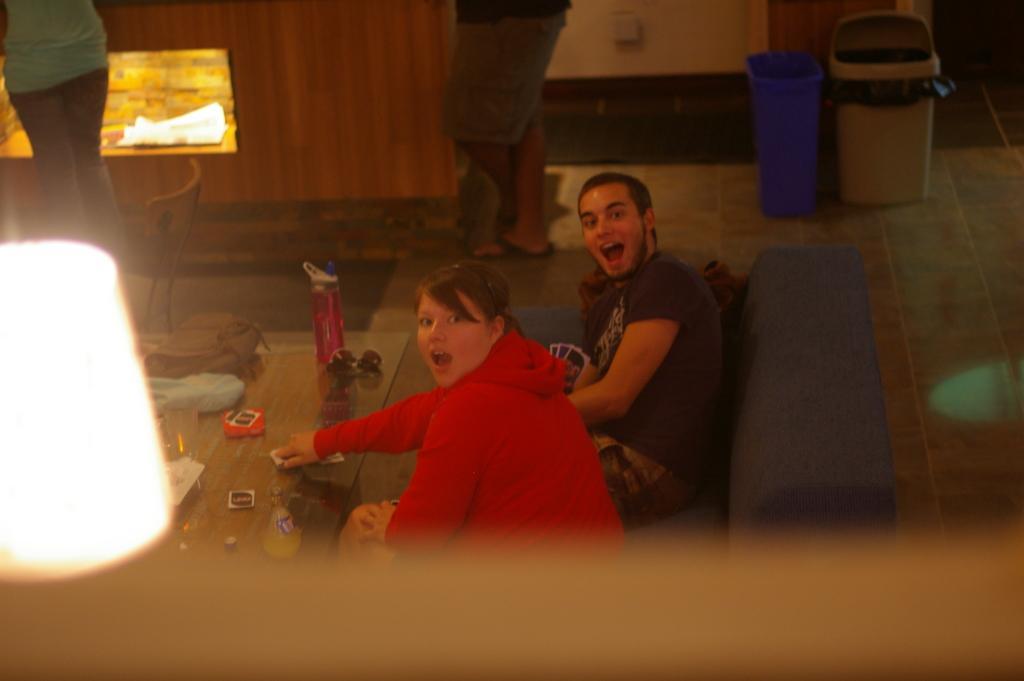Could you give a brief overview of what you see in this image? In the center of the image there are two people sitting on the sofa before them there is a table. We can see a bottle, some toys, bag and a glass which are placed on the table. In the background there are people standing. We can also see some bins. 